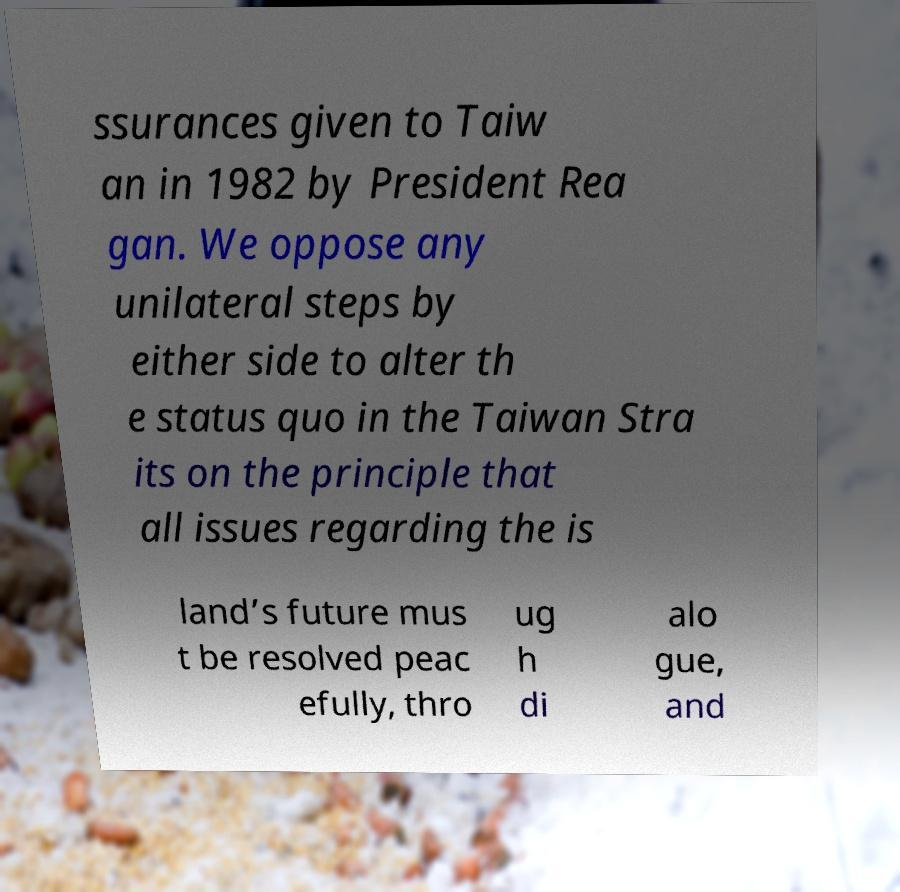Could you assist in decoding the text presented in this image and type it out clearly? ssurances given to Taiw an in 1982 by President Rea gan. We oppose any unilateral steps by either side to alter th e status quo in the Taiwan Stra its on the principle that all issues regarding the is land’s future mus t be resolved peac efully, thro ug h di alo gue, and 